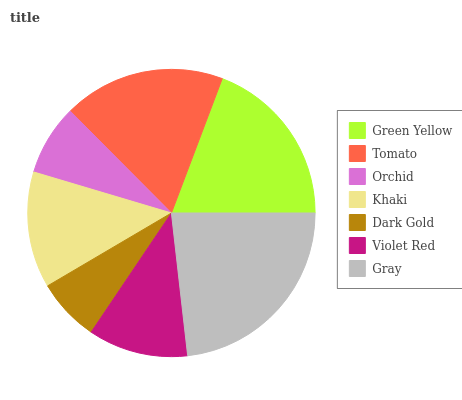Is Dark Gold the minimum?
Answer yes or no. Yes. Is Gray the maximum?
Answer yes or no. Yes. Is Tomato the minimum?
Answer yes or no. No. Is Tomato the maximum?
Answer yes or no. No. Is Green Yellow greater than Tomato?
Answer yes or no. Yes. Is Tomato less than Green Yellow?
Answer yes or no. Yes. Is Tomato greater than Green Yellow?
Answer yes or no. No. Is Green Yellow less than Tomato?
Answer yes or no. No. Is Khaki the high median?
Answer yes or no. Yes. Is Khaki the low median?
Answer yes or no. Yes. Is Orchid the high median?
Answer yes or no. No. Is Dark Gold the low median?
Answer yes or no. No. 